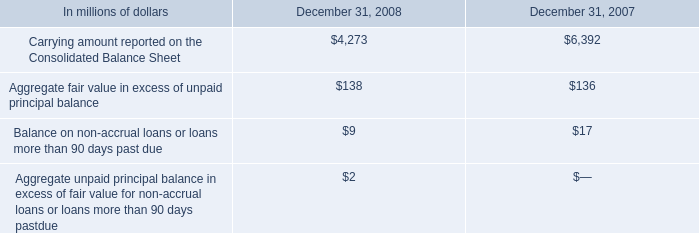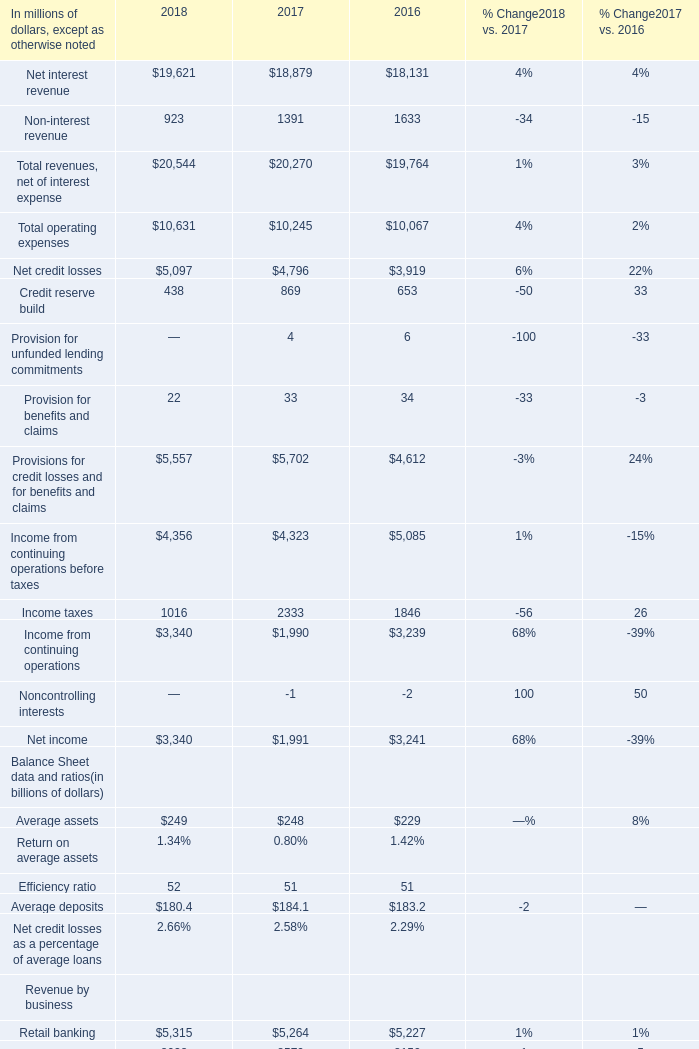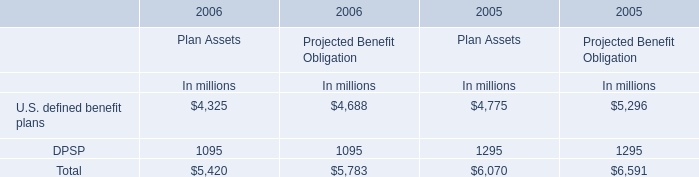What is the sum of Non-interest revenue in 2016 and DPSP of Plan Assets in 2005? (in million) 
Computations: (1633 + 1295)
Answer: 2928.0. 